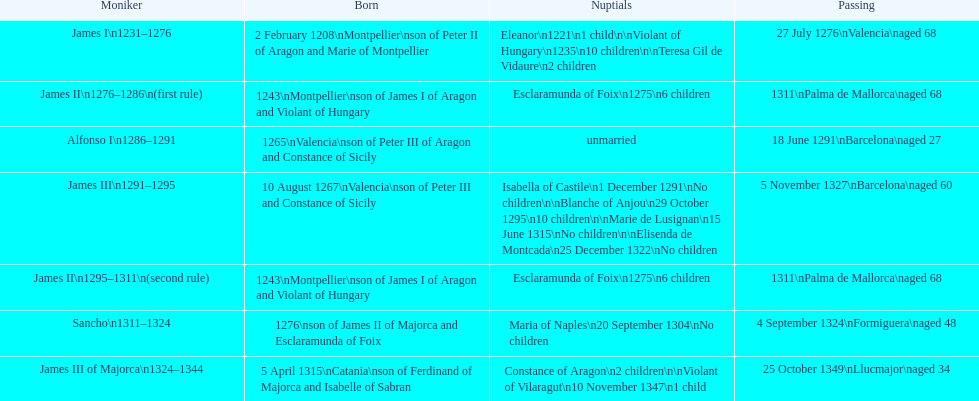Was james iii or sancho born in the year 1276? Sancho. 